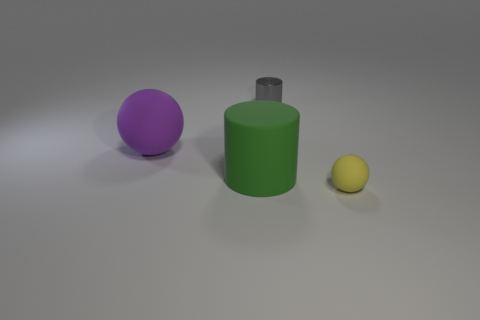Is there a yellow matte object?
Give a very brief answer. Yes. There is another object that is the same size as the purple object; what is its color?
Make the answer very short. Green. What number of green things are the same shape as the small gray thing?
Offer a very short reply. 1. Does the large object on the left side of the big green object have the same material as the big green cylinder?
Ensure brevity in your answer.  Yes. How many cubes are either big gray matte things or yellow matte objects?
Your answer should be compact. 0. There is a purple rubber thing that is behind the matte sphere on the right side of the rubber ball that is left of the yellow sphere; what is its shape?
Ensure brevity in your answer.  Sphere. How many yellow objects have the same size as the gray shiny object?
Provide a short and direct response. 1. Are there any purple things that are behind the rubber ball right of the tiny cylinder?
Ensure brevity in your answer.  Yes. How many objects are gray metal things or small yellow spheres?
Give a very brief answer. 2. What is the color of the ball that is right of the ball behind the ball that is in front of the purple ball?
Make the answer very short. Yellow. 